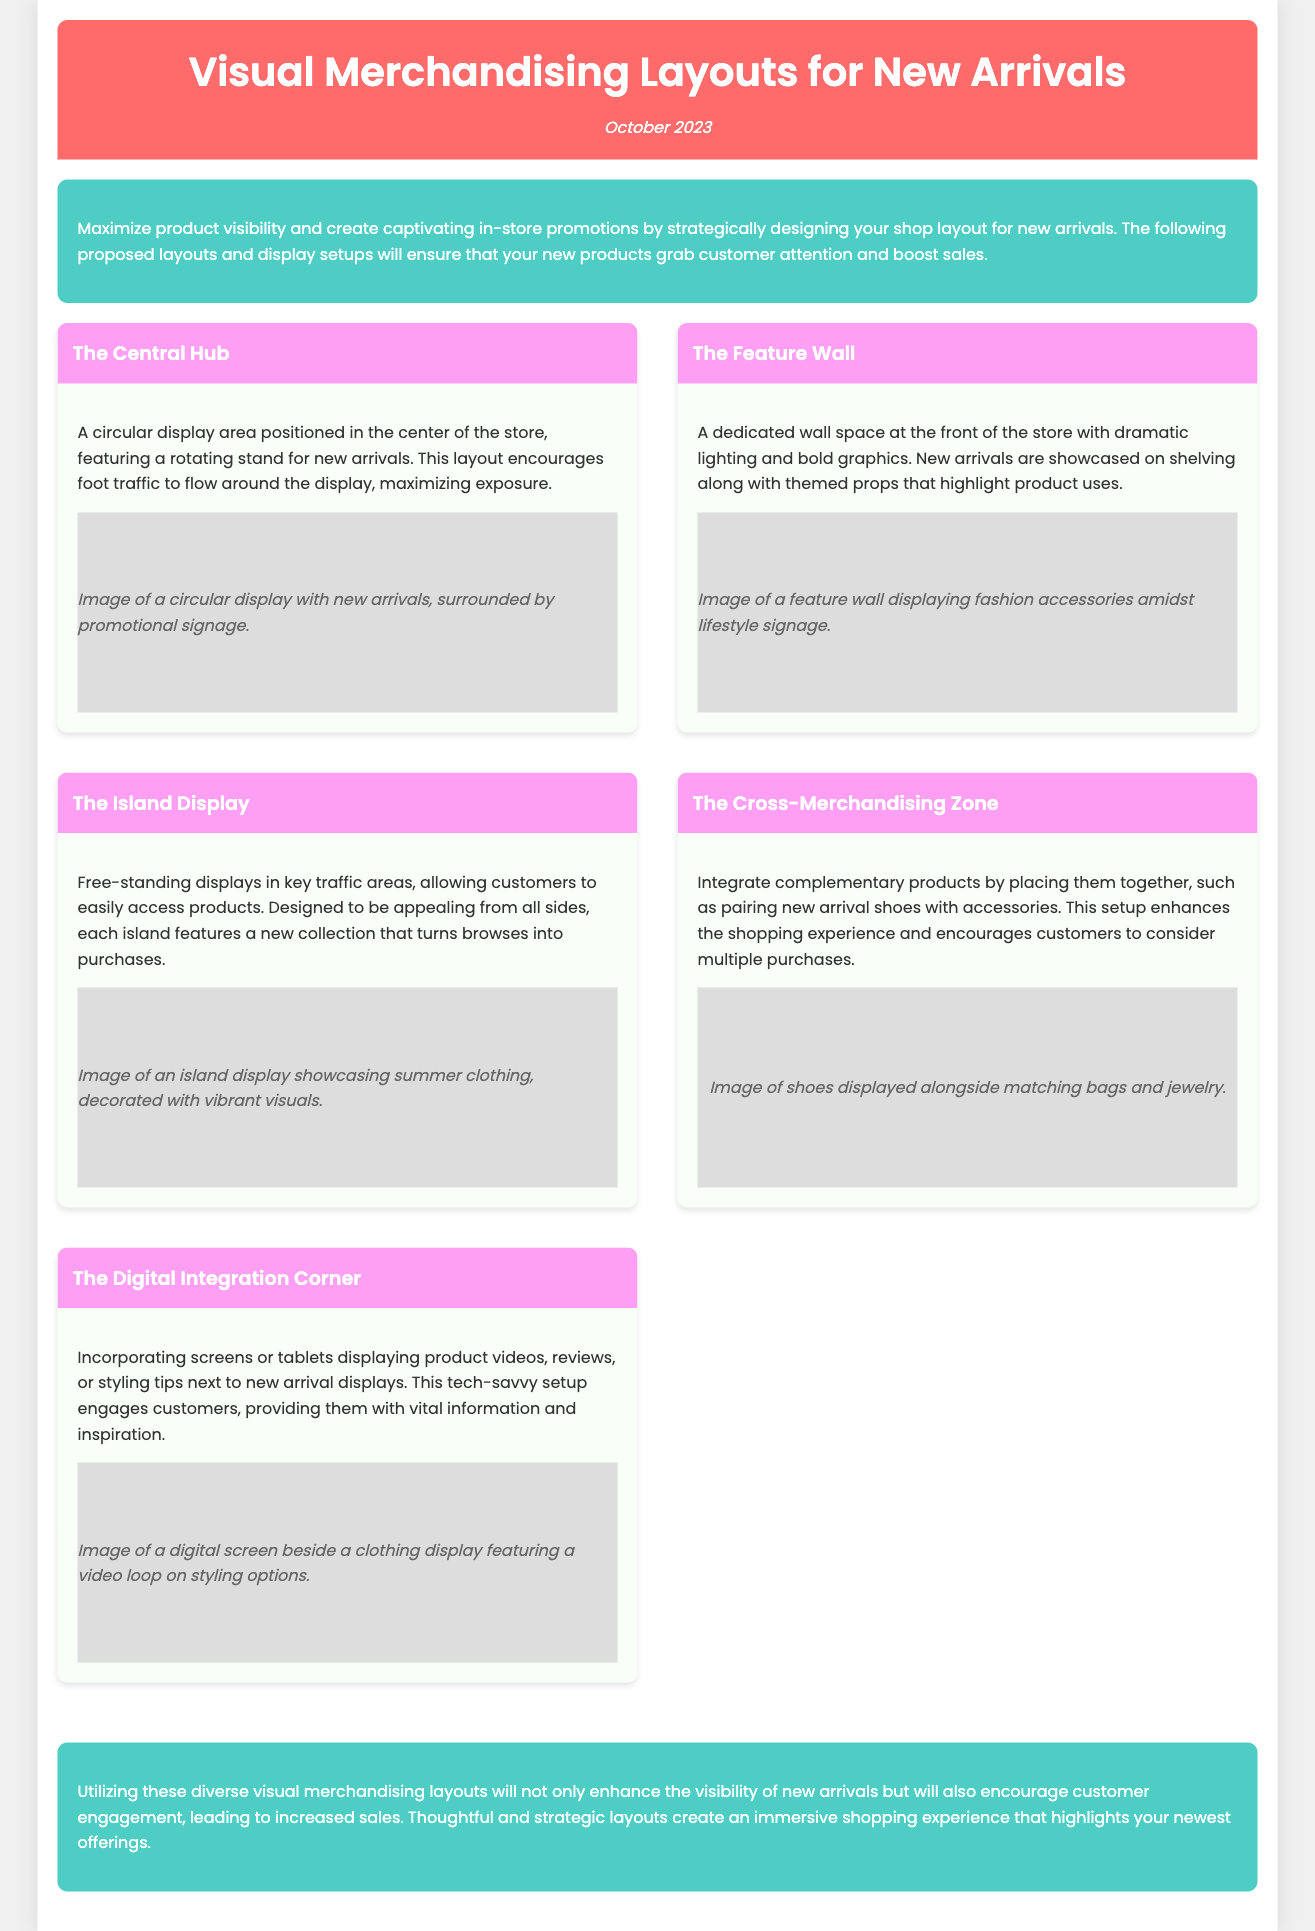What is the title of the document? The title is stated in the header section of the document.
Answer: Visual Merchandising Layouts for New Arrivals What date is mentioned in the document? The date is provided in the header section, indicating when the document was created or published.
Answer: October 2023 Name one of the proposed layouts. The document lists several proposed layouts, each with its own name.
Answer: The Central Hub What is the focus of "The Island Display" layout? The document describes what each layout is designed to achieve.
Answer: Free-standing displays in key traffic areas What type of display is featured in "The Digital Integration Corner"? This layout specifically incorporates a technological element alongside product displays.
Answer: Screens or tablets How do the layouts aim to enhance customer engagement? The document outlines strategies for improving customer interaction with the products.
Answer: Visibility and immersive shopping experience What is highlighted in "The Cross-Merchandising Zone"? This layout emphasizes integrating related products for enhanced shopping.
Answer: Complementary products What color is used for the introductory background? The color of the introductory section is specified in the document.
Answer: Green What effect does hovering have on the layout display? The document details an interaction feature related to the layout design.
Answer: Transform Which layout is described as having a dedicated wall space? The section in the document specifies a unique feature of a particular layout.
Answer: The Feature Wall 